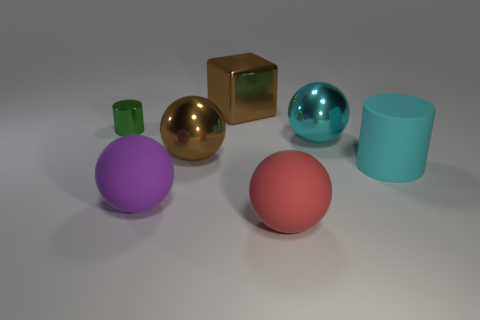What size is the red thing that is made of the same material as the purple sphere?
Your response must be concise. Large. Do the matte sphere that is on the left side of the red matte object and the tiny green shiny cylinder have the same size?
Provide a short and direct response. No. There is a rubber thing left of the red matte object; what shape is it?
Provide a short and direct response. Sphere. What is the color of the matte cylinder that is the same size as the brown shiny cube?
Give a very brief answer. Cyan. There is a large purple matte thing; does it have the same shape as the big shiny object on the right side of the big red matte sphere?
Make the answer very short. Yes. The cylinder that is right of the big matte sphere left of the big red object that is in front of the purple sphere is made of what material?
Ensure brevity in your answer.  Rubber. What number of large things are either red things or purple matte spheres?
Your answer should be compact. 2. What number of other things are there of the same size as the cyan ball?
Offer a terse response. 5. There is a big shiny object left of the large brown metallic block; does it have the same shape as the large red object?
Your response must be concise. Yes. There is a rubber object that is the same shape as the tiny green metal thing; what is its color?
Provide a short and direct response. Cyan. 